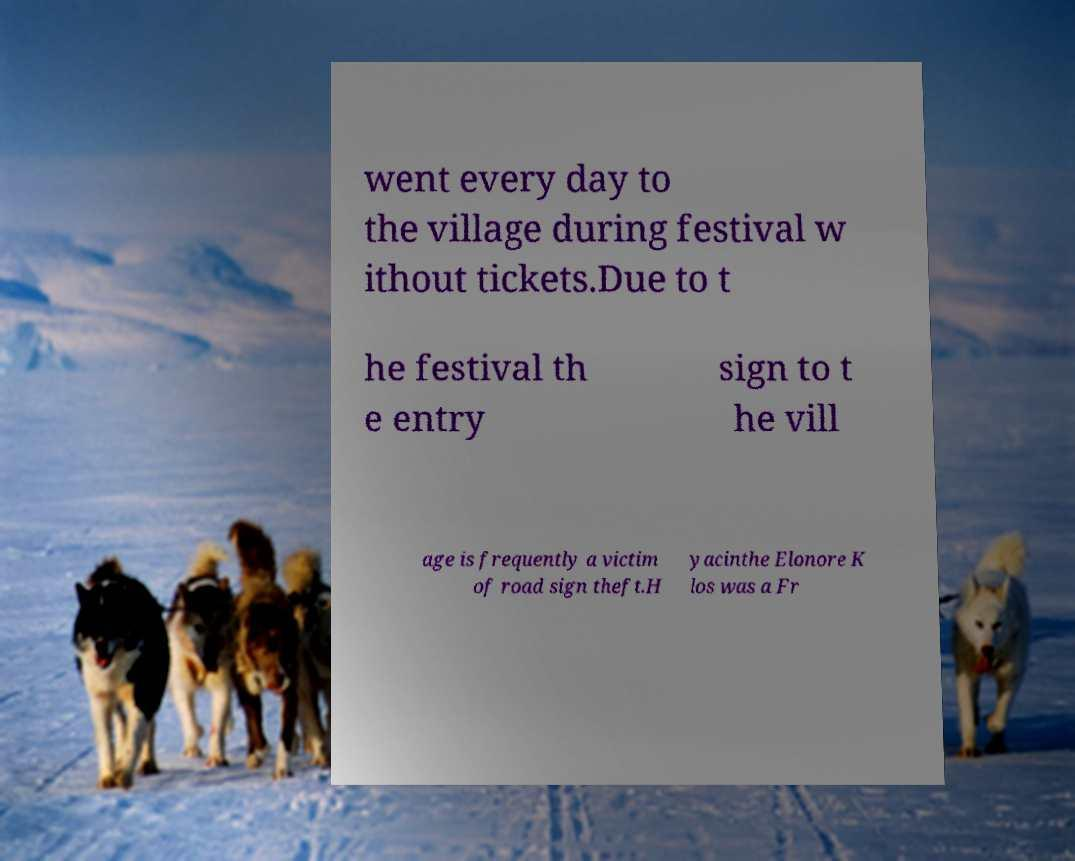Can you accurately transcribe the text from the provided image for me? went every day to the village during festival w ithout tickets.Due to t he festival th e entry sign to t he vill age is frequently a victim of road sign theft.H yacinthe Elonore K los was a Fr 